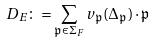Convert formula to latex. <formula><loc_0><loc_0><loc_500><loc_500>\ D _ { E } \colon = \sum _ { \mathfrak p \in \Sigma _ { F } } v _ { \mathfrak p } ( \Delta _ { \mathfrak p } ) \cdot \mathfrak p</formula> 